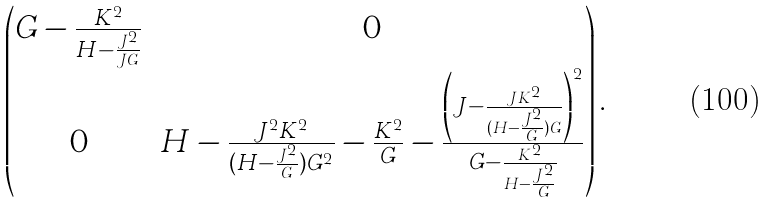<formula> <loc_0><loc_0><loc_500><loc_500>\begin{pmatrix} G - \frac { K ^ { 2 } } { H - \frac { J ^ { 2 } } { J G } } & 0 \\ 0 & H - \frac { J ^ { 2 } K ^ { 2 } } { ( H - \frac { J ^ { 2 } } { G } ) G ^ { 2 } } - \frac { K ^ { 2 } } { G } - \frac { \left ( J - \frac { J K ^ { 2 } } { ( H - \frac { J ^ { 2 } } { G } ) G } \right ) ^ { 2 } } { G - \frac { K ^ { 2 } } { H - \frac { J ^ { 2 } } { G } } } \end{pmatrix} .</formula> 